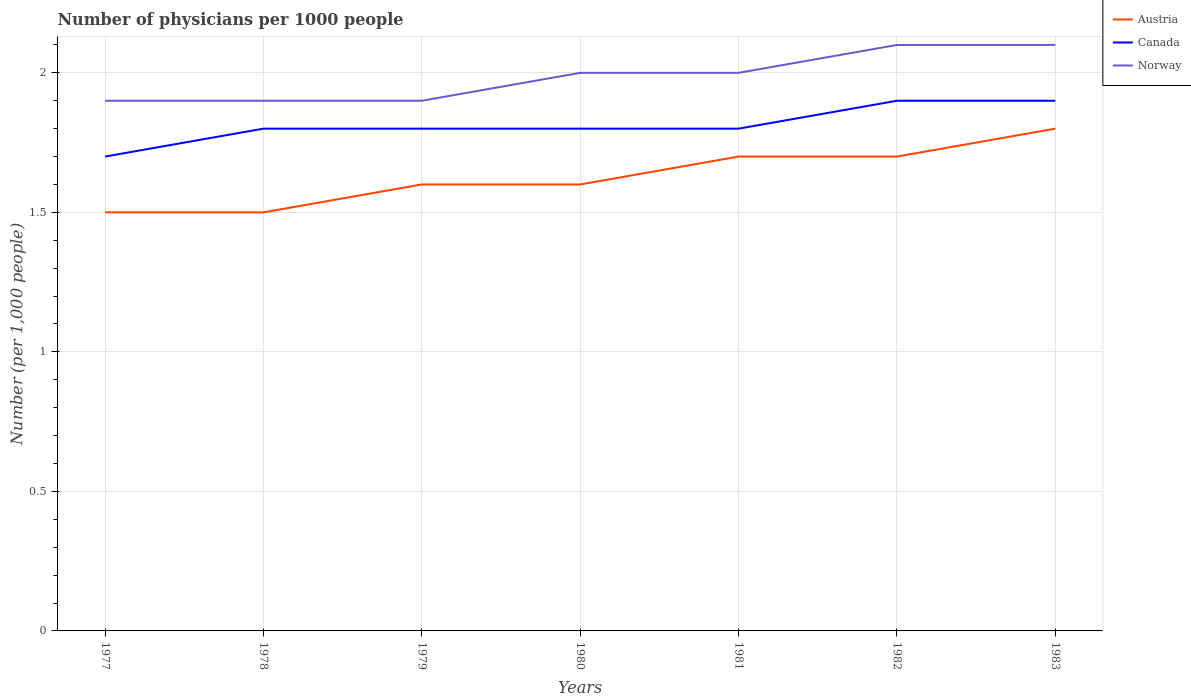How many different coloured lines are there?
Ensure brevity in your answer.  3. Does the line corresponding to Norway intersect with the line corresponding to Austria?
Your response must be concise. No. Across all years, what is the maximum number of physicians in Canada?
Offer a very short reply. 1.7. What is the total number of physicians in Austria in the graph?
Make the answer very short. -0.1. What is the difference between the highest and the second highest number of physicians in Austria?
Give a very brief answer. 0.3. What is the difference between the highest and the lowest number of physicians in Austria?
Offer a terse response. 3. Is the number of physicians in Austria strictly greater than the number of physicians in Norway over the years?
Keep it short and to the point. Yes. How many years are there in the graph?
Provide a short and direct response. 7. Where does the legend appear in the graph?
Provide a succinct answer. Top right. How many legend labels are there?
Give a very brief answer. 3. What is the title of the graph?
Your answer should be very brief. Number of physicians per 1000 people. Does "Tunisia" appear as one of the legend labels in the graph?
Provide a succinct answer. No. What is the label or title of the X-axis?
Your answer should be compact. Years. What is the label or title of the Y-axis?
Keep it short and to the point. Number (per 1,0 people). What is the Number (per 1,000 people) of Norway in 1977?
Provide a short and direct response. 1.9. What is the Number (per 1,000 people) in Austria in 1978?
Your answer should be very brief. 1.5. What is the Number (per 1,000 people) of Canada in 1980?
Offer a terse response. 1.8. What is the Number (per 1,000 people) of Norway in 1980?
Offer a terse response. 2. What is the Number (per 1,000 people) in Austria in 1981?
Provide a short and direct response. 1.7. What is the Number (per 1,000 people) of Canada in 1981?
Offer a very short reply. 1.8. What is the Number (per 1,000 people) of Norway in 1981?
Your answer should be very brief. 2. What is the Number (per 1,000 people) in Austria in 1982?
Your answer should be compact. 1.7. What is the Number (per 1,000 people) of Canada in 1982?
Your answer should be very brief. 1.9. What is the Number (per 1,000 people) in Austria in 1983?
Give a very brief answer. 1.8. Across all years, what is the maximum Number (per 1,000 people) of Canada?
Provide a short and direct response. 1.9. Across all years, what is the maximum Number (per 1,000 people) of Norway?
Offer a terse response. 2.1. Across all years, what is the minimum Number (per 1,000 people) in Norway?
Keep it short and to the point. 1.9. What is the total Number (per 1,000 people) of Austria in the graph?
Ensure brevity in your answer.  11.4. What is the difference between the Number (per 1,000 people) of Austria in 1977 and that in 1978?
Your answer should be compact. 0. What is the difference between the Number (per 1,000 people) of Canada in 1977 and that in 1978?
Make the answer very short. -0.1. What is the difference between the Number (per 1,000 people) in Austria in 1977 and that in 1980?
Give a very brief answer. -0.1. What is the difference between the Number (per 1,000 people) in Canada in 1977 and that in 1980?
Provide a succinct answer. -0.1. What is the difference between the Number (per 1,000 people) in Norway in 1977 and that in 1980?
Your answer should be very brief. -0.1. What is the difference between the Number (per 1,000 people) in Austria in 1977 and that in 1981?
Ensure brevity in your answer.  -0.2. What is the difference between the Number (per 1,000 people) of Canada in 1977 and that in 1981?
Your response must be concise. -0.1. What is the difference between the Number (per 1,000 people) in Austria in 1977 and that in 1982?
Provide a short and direct response. -0.2. What is the difference between the Number (per 1,000 people) of Canada in 1977 and that in 1983?
Provide a succinct answer. -0.2. What is the difference between the Number (per 1,000 people) in Norway in 1977 and that in 1983?
Provide a succinct answer. -0.2. What is the difference between the Number (per 1,000 people) in Norway in 1978 and that in 1979?
Offer a terse response. 0. What is the difference between the Number (per 1,000 people) of Austria in 1978 and that in 1980?
Keep it short and to the point. -0.1. What is the difference between the Number (per 1,000 people) of Austria in 1978 and that in 1981?
Offer a terse response. -0.2. What is the difference between the Number (per 1,000 people) in Austria in 1978 and that in 1982?
Give a very brief answer. -0.2. What is the difference between the Number (per 1,000 people) of Norway in 1978 and that in 1982?
Provide a succinct answer. -0.2. What is the difference between the Number (per 1,000 people) in Austria in 1978 and that in 1983?
Keep it short and to the point. -0.3. What is the difference between the Number (per 1,000 people) in Norway in 1978 and that in 1983?
Your response must be concise. -0.2. What is the difference between the Number (per 1,000 people) in Canada in 1979 and that in 1981?
Provide a short and direct response. 0. What is the difference between the Number (per 1,000 people) of Canada in 1979 and that in 1982?
Offer a very short reply. -0.1. What is the difference between the Number (per 1,000 people) in Austria in 1979 and that in 1983?
Your answer should be very brief. -0.2. What is the difference between the Number (per 1,000 people) of Canada in 1979 and that in 1983?
Your response must be concise. -0.1. What is the difference between the Number (per 1,000 people) of Austria in 1980 and that in 1981?
Your answer should be compact. -0.1. What is the difference between the Number (per 1,000 people) in Canada in 1980 and that in 1981?
Your response must be concise. 0. What is the difference between the Number (per 1,000 people) of Norway in 1980 and that in 1981?
Offer a very short reply. 0. What is the difference between the Number (per 1,000 people) of Austria in 1980 and that in 1983?
Give a very brief answer. -0.2. What is the difference between the Number (per 1,000 people) in Canada in 1980 and that in 1983?
Ensure brevity in your answer.  -0.1. What is the difference between the Number (per 1,000 people) in Austria in 1981 and that in 1982?
Your answer should be very brief. 0. What is the difference between the Number (per 1,000 people) of Canada in 1981 and that in 1982?
Offer a very short reply. -0.1. What is the difference between the Number (per 1,000 people) in Norway in 1981 and that in 1982?
Your answer should be very brief. -0.1. What is the difference between the Number (per 1,000 people) of Austria in 1981 and that in 1983?
Your answer should be compact. -0.1. What is the difference between the Number (per 1,000 people) in Canada in 1981 and that in 1983?
Offer a very short reply. -0.1. What is the difference between the Number (per 1,000 people) in Norway in 1981 and that in 1983?
Make the answer very short. -0.1. What is the difference between the Number (per 1,000 people) of Norway in 1982 and that in 1983?
Keep it short and to the point. 0. What is the difference between the Number (per 1,000 people) in Austria in 1977 and the Number (per 1,000 people) in Norway in 1978?
Your response must be concise. -0.4. What is the difference between the Number (per 1,000 people) in Canada in 1977 and the Number (per 1,000 people) in Norway in 1978?
Offer a terse response. -0.2. What is the difference between the Number (per 1,000 people) of Canada in 1977 and the Number (per 1,000 people) of Norway in 1979?
Provide a short and direct response. -0.2. What is the difference between the Number (per 1,000 people) of Austria in 1977 and the Number (per 1,000 people) of Norway in 1980?
Your response must be concise. -0.5. What is the difference between the Number (per 1,000 people) of Canada in 1977 and the Number (per 1,000 people) of Norway in 1980?
Ensure brevity in your answer.  -0.3. What is the difference between the Number (per 1,000 people) in Austria in 1977 and the Number (per 1,000 people) in Canada in 1981?
Provide a short and direct response. -0.3. What is the difference between the Number (per 1,000 people) in Austria in 1977 and the Number (per 1,000 people) in Norway in 1981?
Keep it short and to the point. -0.5. What is the difference between the Number (per 1,000 people) in Canada in 1977 and the Number (per 1,000 people) in Norway in 1981?
Offer a terse response. -0.3. What is the difference between the Number (per 1,000 people) in Canada in 1977 and the Number (per 1,000 people) in Norway in 1982?
Your response must be concise. -0.4. What is the difference between the Number (per 1,000 people) in Austria in 1977 and the Number (per 1,000 people) in Norway in 1983?
Keep it short and to the point. -0.6. What is the difference between the Number (per 1,000 people) of Austria in 1978 and the Number (per 1,000 people) of Canada in 1979?
Your response must be concise. -0.3. What is the difference between the Number (per 1,000 people) in Canada in 1978 and the Number (per 1,000 people) in Norway in 1979?
Provide a short and direct response. -0.1. What is the difference between the Number (per 1,000 people) of Austria in 1978 and the Number (per 1,000 people) of Norway in 1980?
Offer a terse response. -0.5. What is the difference between the Number (per 1,000 people) of Canada in 1978 and the Number (per 1,000 people) of Norway in 1980?
Your answer should be compact. -0.2. What is the difference between the Number (per 1,000 people) of Austria in 1978 and the Number (per 1,000 people) of Canada in 1981?
Give a very brief answer. -0.3. What is the difference between the Number (per 1,000 people) of Canada in 1978 and the Number (per 1,000 people) of Norway in 1981?
Provide a short and direct response. -0.2. What is the difference between the Number (per 1,000 people) in Austria in 1978 and the Number (per 1,000 people) in Canada in 1982?
Your response must be concise. -0.4. What is the difference between the Number (per 1,000 people) of Canada in 1978 and the Number (per 1,000 people) of Norway in 1982?
Ensure brevity in your answer.  -0.3. What is the difference between the Number (per 1,000 people) in Austria in 1978 and the Number (per 1,000 people) in Norway in 1983?
Your answer should be compact. -0.6. What is the difference between the Number (per 1,000 people) of Canada in 1978 and the Number (per 1,000 people) of Norway in 1983?
Your answer should be very brief. -0.3. What is the difference between the Number (per 1,000 people) in Austria in 1979 and the Number (per 1,000 people) in Norway in 1980?
Make the answer very short. -0.4. What is the difference between the Number (per 1,000 people) in Canada in 1979 and the Number (per 1,000 people) in Norway in 1980?
Make the answer very short. -0.2. What is the difference between the Number (per 1,000 people) of Austria in 1979 and the Number (per 1,000 people) of Canada in 1981?
Make the answer very short. -0.2. What is the difference between the Number (per 1,000 people) of Austria in 1979 and the Number (per 1,000 people) of Canada in 1982?
Offer a very short reply. -0.3. What is the difference between the Number (per 1,000 people) in Austria in 1979 and the Number (per 1,000 people) in Norway in 1982?
Give a very brief answer. -0.5. What is the difference between the Number (per 1,000 people) of Canada in 1979 and the Number (per 1,000 people) of Norway in 1982?
Offer a very short reply. -0.3. What is the difference between the Number (per 1,000 people) in Austria in 1979 and the Number (per 1,000 people) in Canada in 1983?
Offer a very short reply. -0.3. What is the difference between the Number (per 1,000 people) in Austria in 1979 and the Number (per 1,000 people) in Norway in 1983?
Your answer should be very brief. -0.5. What is the difference between the Number (per 1,000 people) in Austria in 1980 and the Number (per 1,000 people) in Canada in 1981?
Make the answer very short. -0.2. What is the difference between the Number (per 1,000 people) in Canada in 1980 and the Number (per 1,000 people) in Norway in 1982?
Provide a succinct answer. -0.3. What is the difference between the Number (per 1,000 people) in Austria in 1980 and the Number (per 1,000 people) in Norway in 1983?
Provide a succinct answer. -0.5. What is the difference between the Number (per 1,000 people) in Canada in 1980 and the Number (per 1,000 people) in Norway in 1983?
Your response must be concise. -0.3. What is the difference between the Number (per 1,000 people) of Austria in 1981 and the Number (per 1,000 people) of Canada in 1982?
Ensure brevity in your answer.  -0.2. What is the difference between the Number (per 1,000 people) in Austria in 1981 and the Number (per 1,000 people) in Norway in 1982?
Make the answer very short. -0.4. What is the difference between the Number (per 1,000 people) in Canada in 1981 and the Number (per 1,000 people) in Norway in 1982?
Your answer should be very brief. -0.3. What is the average Number (per 1,000 people) of Austria per year?
Provide a succinct answer. 1.63. What is the average Number (per 1,000 people) in Canada per year?
Provide a succinct answer. 1.81. What is the average Number (per 1,000 people) of Norway per year?
Ensure brevity in your answer.  1.99. In the year 1978, what is the difference between the Number (per 1,000 people) of Austria and Number (per 1,000 people) of Norway?
Provide a short and direct response. -0.4. In the year 1979, what is the difference between the Number (per 1,000 people) in Austria and Number (per 1,000 people) in Norway?
Your answer should be compact. -0.3. In the year 1980, what is the difference between the Number (per 1,000 people) of Austria and Number (per 1,000 people) of Norway?
Offer a terse response. -0.4. In the year 1980, what is the difference between the Number (per 1,000 people) of Canada and Number (per 1,000 people) of Norway?
Provide a succinct answer. -0.2. In the year 1981, what is the difference between the Number (per 1,000 people) of Austria and Number (per 1,000 people) of Canada?
Provide a succinct answer. -0.1. In the year 1982, what is the difference between the Number (per 1,000 people) of Austria and Number (per 1,000 people) of Norway?
Give a very brief answer. -0.4. In the year 1983, what is the difference between the Number (per 1,000 people) of Canada and Number (per 1,000 people) of Norway?
Offer a terse response. -0.2. What is the ratio of the Number (per 1,000 people) in Austria in 1977 to that in 1978?
Your response must be concise. 1. What is the ratio of the Number (per 1,000 people) of Canada in 1977 to that in 1978?
Keep it short and to the point. 0.94. What is the ratio of the Number (per 1,000 people) in Canada in 1977 to that in 1979?
Ensure brevity in your answer.  0.94. What is the ratio of the Number (per 1,000 people) of Norway in 1977 to that in 1979?
Keep it short and to the point. 1. What is the ratio of the Number (per 1,000 people) of Austria in 1977 to that in 1981?
Give a very brief answer. 0.88. What is the ratio of the Number (per 1,000 people) in Austria in 1977 to that in 1982?
Your answer should be very brief. 0.88. What is the ratio of the Number (per 1,000 people) of Canada in 1977 to that in 1982?
Your response must be concise. 0.89. What is the ratio of the Number (per 1,000 people) of Norway in 1977 to that in 1982?
Keep it short and to the point. 0.9. What is the ratio of the Number (per 1,000 people) in Austria in 1977 to that in 1983?
Offer a very short reply. 0.83. What is the ratio of the Number (per 1,000 people) of Canada in 1977 to that in 1983?
Your response must be concise. 0.89. What is the ratio of the Number (per 1,000 people) in Norway in 1977 to that in 1983?
Your answer should be very brief. 0.9. What is the ratio of the Number (per 1,000 people) in Austria in 1978 to that in 1979?
Offer a terse response. 0.94. What is the ratio of the Number (per 1,000 people) in Canada in 1978 to that in 1979?
Ensure brevity in your answer.  1. What is the ratio of the Number (per 1,000 people) in Austria in 1978 to that in 1980?
Give a very brief answer. 0.94. What is the ratio of the Number (per 1,000 people) of Canada in 1978 to that in 1980?
Make the answer very short. 1. What is the ratio of the Number (per 1,000 people) of Norway in 1978 to that in 1980?
Provide a short and direct response. 0.95. What is the ratio of the Number (per 1,000 people) of Austria in 1978 to that in 1981?
Your response must be concise. 0.88. What is the ratio of the Number (per 1,000 people) of Canada in 1978 to that in 1981?
Your answer should be very brief. 1. What is the ratio of the Number (per 1,000 people) of Norway in 1978 to that in 1981?
Your answer should be very brief. 0.95. What is the ratio of the Number (per 1,000 people) in Austria in 1978 to that in 1982?
Your answer should be compact. 0.88. What is the ratio of the Number (per 1,000 people) in Norway in 1978 to that in 1982?
Offer a terse response. 0.9. What is the ratio of the Number (per 1,000 people) of Austria in 1978 to that in 1983?
Offer a very short reply. 0.83. What is the ratio of the Number (per 1,000 people) in Canada in 1978 to that in 1983?
Provide a succinct answer. 0.95. What is the ratio of the Number (per 1,000 people) in Norway in 1978 to that in 1983?
Your response must be concise. 0.9. What is the ratio of the Number (per 1,000 people) in Canada in 1979 to that in 1980?
Keep it short and to the point. 1. What is the ratio of the Number (per 1,000 people) of Norway in 1979 to that in 1980?
Make the answer very short. 0.95. What is the ratio of the Number (per 1,000 people) in Austria in 1979 to that in 1981?
Ensure brevity in your answer.  0.94. What is the ratio of the Number (per 1,000 people) in Norway in 1979 to that in 1981?
Ensure brevity in your answer.  0.95. What is the ratio of the Number (per 1,000 people) of Austria in 1979 to that in 1982?
Provide a succinct answer. 0.94. What is the ratio of the Number (per 1,000 people) in Canada in 1979 to that in 1982?
Your response must be concise. 0.95. What is the ratio of the Number (per 1,000 people) of Norway in 1979 to that in 1982?
Offer a terse response. 0.9. What is the ratio of the Number (per 1,000 people) in Austria in 1979 to that in 1983?
Your response must be concise. 0.89. What is the ratio of the Number (per 1,000 people) of Norway in 1979 to that in 1983?
Keep it short and to the point. 0.9. What is the ratio of the Number (per 1,000 people) of Canada in 1980 to that in 1981?
Provide a short and direct response. 1. What is the ratio of the Number (per 1,000 people) of Austria in 1980 to that in 1982?
Your answer should be compact. 0.94. What is the ratio of the Number (per 1,000 people) in Canada in 1980 to that in 1982?
Offer a terse response. 0.95. What is the ratio of the Number (per 1,000 people) of Canada in 1980 to that in 1983?
Keep it short and to the point. 0.95. What is the ratio of the Number (per 1,000 people) in Norway in 1980 to that in 1983?
Ensure brevity in your answer.  0.95. What is the ratio of the Number (per 1,000 people) in Canada in 1981 to that in 1982?
Your answer should be very brief. 0.95. What is the ratio of the Number (per 1,000 people) in Canada in 1981 to that in 1983?
Ensure brevity in your answer.  0.95. What is the ratio of the Number (per 1,000 people) of Norway in 1981 to that in 1983?
Make the answer very short. 0.95. What is the ratio of the Number (per 1,000 people) in Austria in 1982 to that in 1983?
Keep it short and to the point. 0.94. What is the ratio of the Number (per 1,000 people) in Norway in 1982 to that in 1983?
Give a very brief answer. 1. What is the difference between the highest and the second highest Number (per 1,000 people) of Austria?
Make the answer very short. 0.1. What is the difference between the highest and the lowest Number (per 1,000 people) in Austria?
Give a very brief answer. 0.3. 